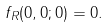Convert formula to latex. <formula><loc_0><loc_0><loc_500><loc_500>f _ { R } ( 0 , 0 ; 0 ) = 0 .</formula> 